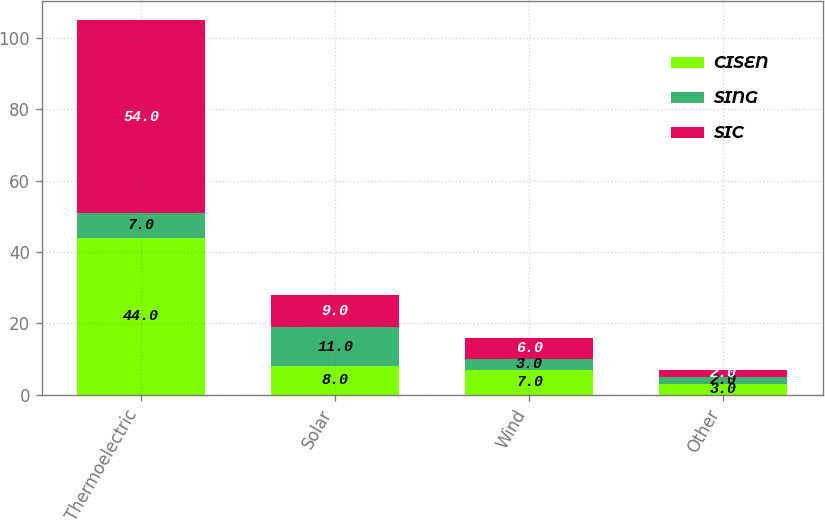Convert chart to OTSL. <chart><loc_0><loc_0><loc_500><loc_500><stacked_bar_chart><ecel><fcel>Thermoelectric<fcel>Solar<fcel>Wind<fcel>Other<nl><fcel>CISEN<fcel>44<fcel>8<fcel>7<fcel>3<nl><fcel>SING<fcel>7<fcel>11<fcel>3<fcel>2<nl><fcel>SIC<fcel>54<fcel>9<fcel>6<fcel>2<nl></chart> 